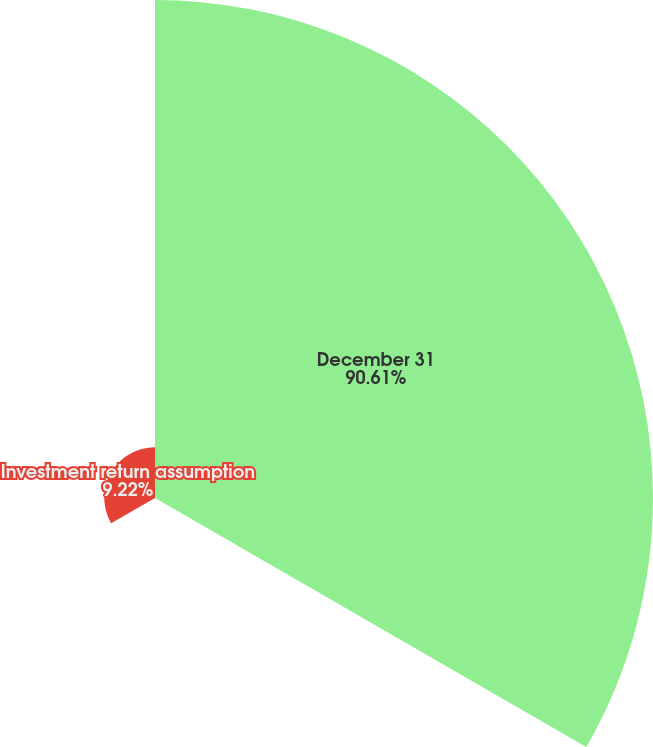Convert chart. <chart><loc_0><loc_0><loc_500><loc_500><pie_chart><fcel>December 31<fcel>Discount rate<fcel>Investment return assumption<nl><fcel>90.61%<fcel>0.17%<fcel>9.22%<nl></chart> 